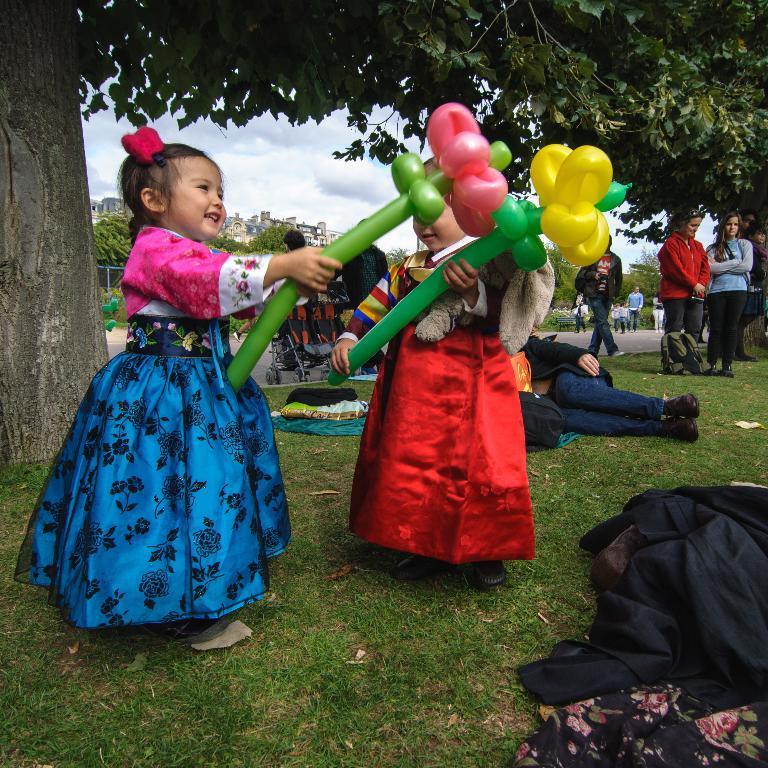Can you describe this image briefly? In this picture I can see there is a girl standing and holding the balloon and there are some people lying on the grass and some of them are standing. In the backdrop I can see there are trees and buildings. 